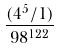<formula> <loc_0><loc_0><loc_500><loc_500>\frac { ( 4 ^ { 5 } / 1 ) } { 9 8 ^ { 1 2 2 } }</formula> 